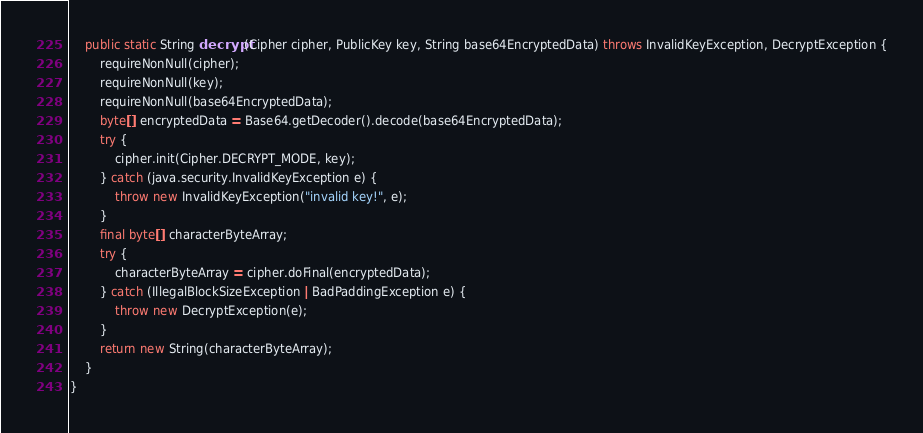Convert code to text. <code><loc_0><loc_0><loc_500><loc_500><_Java_>	public static String decrypt(Cipher cipher, PublicKey key, String base64EncryptedData) throws InvalidKeyException, DecryptException {
		requireNonNull(cipher);
		requireNonNull(key);
		requireNonNull(base64EncryptedData);
		byte[] encryptedData = Base64.getDecoder().decode(base64EncryptedData);
		try {
			cipher.init(Cipher.DECRYPT_MODE, key);
		} catch (java.security.InvalidKeyException e) {
			throw new InvalidKeyException("invalid key!", e);
		}
		final byte[] characterByteArray;
		try {
			characterByteArray = cipher.doFinal(encryptedData);
		} catch (IllegalBlockSizeException | BadPaddingException e) {
			throw new DecryptException(e);
		}
		return new String(characterByteArray);
	}
}
</code> 